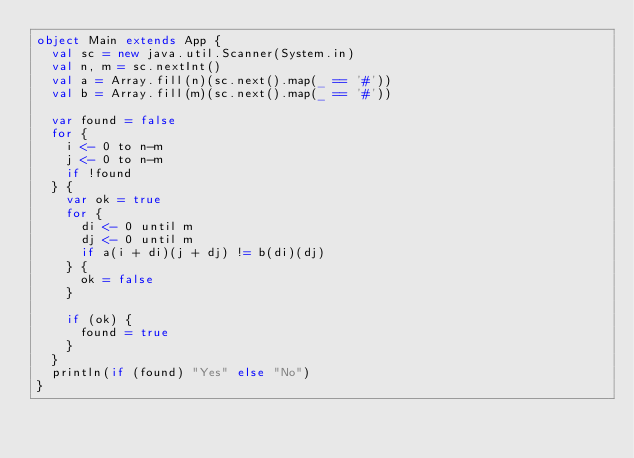Convert code to text. <code><loc_0><loc_0><loc_500><loc_500><_Scala_>object Main extends App {
  val sc = new java.util.Scanner(System.in)
  val n, m = sc.nextInt()
  val a = Array.fill(n)(sc.next().map(_ == '#'))
  val b = Array.fill(m)(sc.next().map(_ == '#'))

  var found = false
  for {
    i <- 0 to n-m
    j <- 0 to n-m
    if !found
  } {
    var ok = true
    for {
      di <- 0 until m
      dj <- 0 until m
      if a(i + di)(j + dj) != b(di)(dj)
    } {
      ok = false
    }

    if (ok) {
      found = true
    }
  }
  println(if (found) "Yes" else "No")
}
</code> 